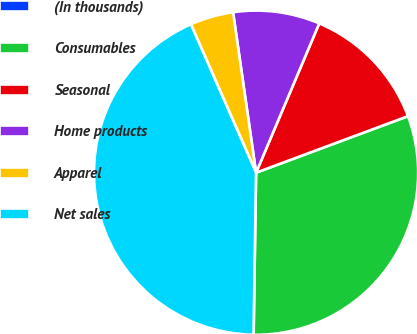<chart> <loc_0><loc_0><loc_500><loc_500><pie_chart><fcel>(In thousands)<fcel>Consumables<fcel>Seasonal<fcel>Home products<fcel>Apparel<fcel>Net sales<nl><fcel>0.01%<fcel>30.91%<fcel>12.96%<fcel>8.64%<fcel>4.32%<fcel>43.17%<nl></chart> 